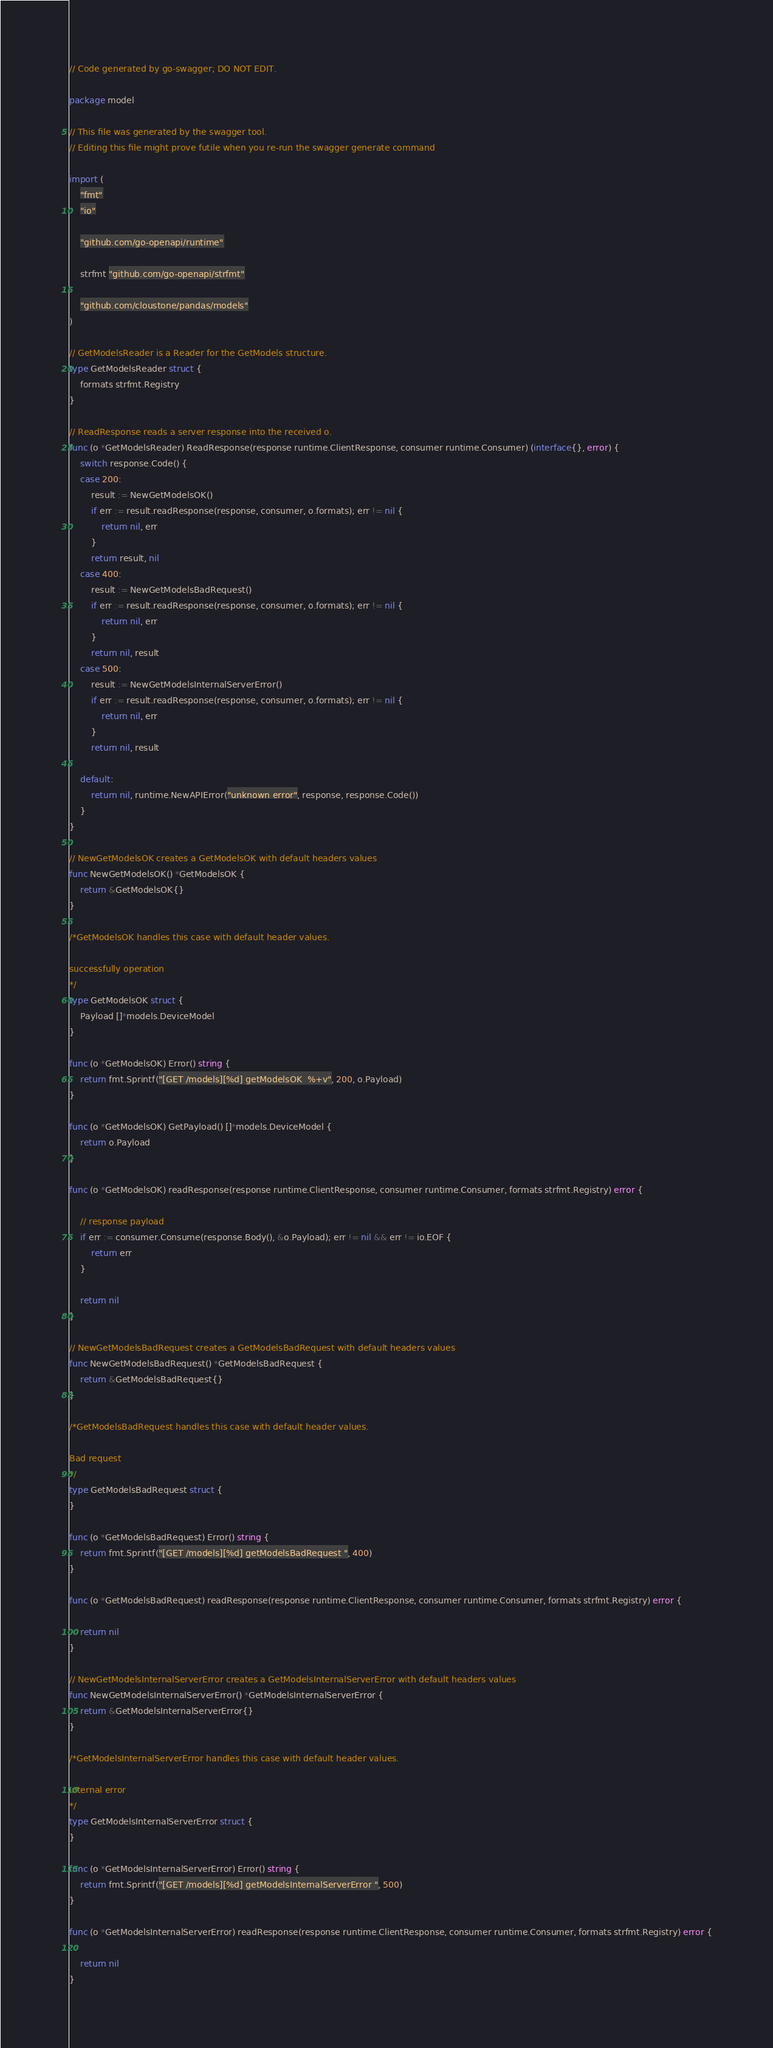<code> <loc_0><loc_0><loc_500><loc_500><_Go_>// Code generated by go-swagger; DO NOT EDIT.

package model

// This file was generated by the swagger tool.
// Editing this file might prove futile when you re-run the swagger generate command

import (
	"fmt"
	"io"

	"github.com/go-openapi/runtime"

	strfmt "github.com/go-openapi/strfmt"

	"github.com/cloustone/pandas/models"
)

// GetModelsReader is a Reader for the GetModels structure.
type GetModelsReader struct {
	formats strfmt.Registry
}

// ReadResponse reads a server response into the received o.
func (o *GetModelsReader) ReadResponse(response runtime.ClientResponse, consumer runtime.Consumer) (interface{}, error) {
	switch response.Code() {
	case 200:
		result := NewGetModelsOK()
		if err := result.readResponse(response, consumer, o.formats); err != nil {
			return nil, err
		}
		return result, nil
	case 400:
		result := NewGetModelsBadRequest()
		if err := result.readResponse(response, consumer, o.formats); err != nil {
			return nil, err
		}
		return nil, result
	case 500:
		result := NewGetModelsInternalServerError()
		if err := result.readResponse(response, consumer, o.formats); err != nil {
			return nil, err
		}
		return nil, result

	default:
		return nil, runtime.NewAPIError("unknown error", response, response.Code())
	}
}

// NewGetModelsOK creates a GetModelsOK with default headers values
func NewGetModelsOK() *GetModelsOK {
	return &GetModelsOK{}
}

/*GetModelsOK handles this case with default header values.

successfully operation
*/
type GetModelsOK struct {
	Payload []*models.DeviceModel
}

func (o *GetModelsOK) Error() string {
	return fmt.Sprintf("[GET /models][%d] getModelsOK  %+v", 200, o.Payload)
}

func (o *GetModelsOK) GetPayload() []*models.DeviceModel {
	return o.Payload
}

func (o *GetModelsOK) readResponse(response runtime.ClientResponse, consumer runtime.Consumer, formats strfmt.Registry) error {

	// response payload
	if err := consumer.Consume(response.Body(), &o.Payload); err != nil && err != io.EOF {
		return err
	}

	return nil
}

// NewGetModelsBadRequest creates a GetModelsBadRequest with default headers values
func NewGetModelsBadRequest() *GetModelsBadRequest {
	return &GetModelsBadRequest{}
}

/*GetModelsBadRequest handles this case with default header values.

Bad request
*/
type GetModelsBadRequest struct {
}

func (o *GetModelsBadRequest) Error() string {
	return fmt.Sprintf("[GET /models][%d] getModelsBadRequest ", 400)
}

func (o *GetModelsBadRequest) readResponse(response runtime.ClientResponse, consumer runtime.Consumer, formats strfmt.Registry) error {

	return nil
}

// NewGetModelsInternalServerError creates a GetModelsInternalServerError with default headers values
func NewGetModelsInternalServerError() *GetModelsInternalServerError {
	return &GetModelsInternalServerError{}
}

/*GetModelsInternalServerError handles this case with default header values.

Internal error
*/
type GetModelsInternalServerError struct {
}

func (o *GetModelsInternalServerError) Error() string {
	return fmt.Sprintf("[GET /models][%d] getModelsInternalServerError ", 500)
}

func (o *GetModelsInternalServerError) readResponse(response runtime.ClientResponse, consumer runtime.Consumer, formats strfmt.Registry) error {

	return nil
}
</code> 